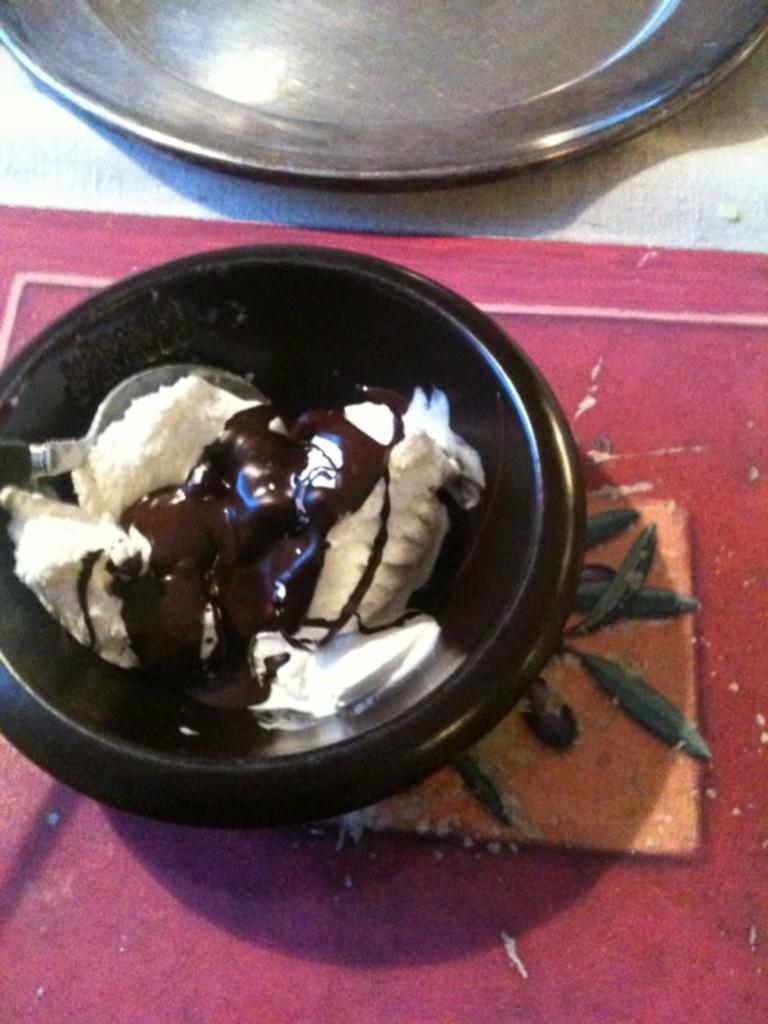Could you give a brief overview of what you see in this image? In this image there is a brown color bowl on the red color floor. In the bowl there is an ice cream. At the top there is a steel plate. 